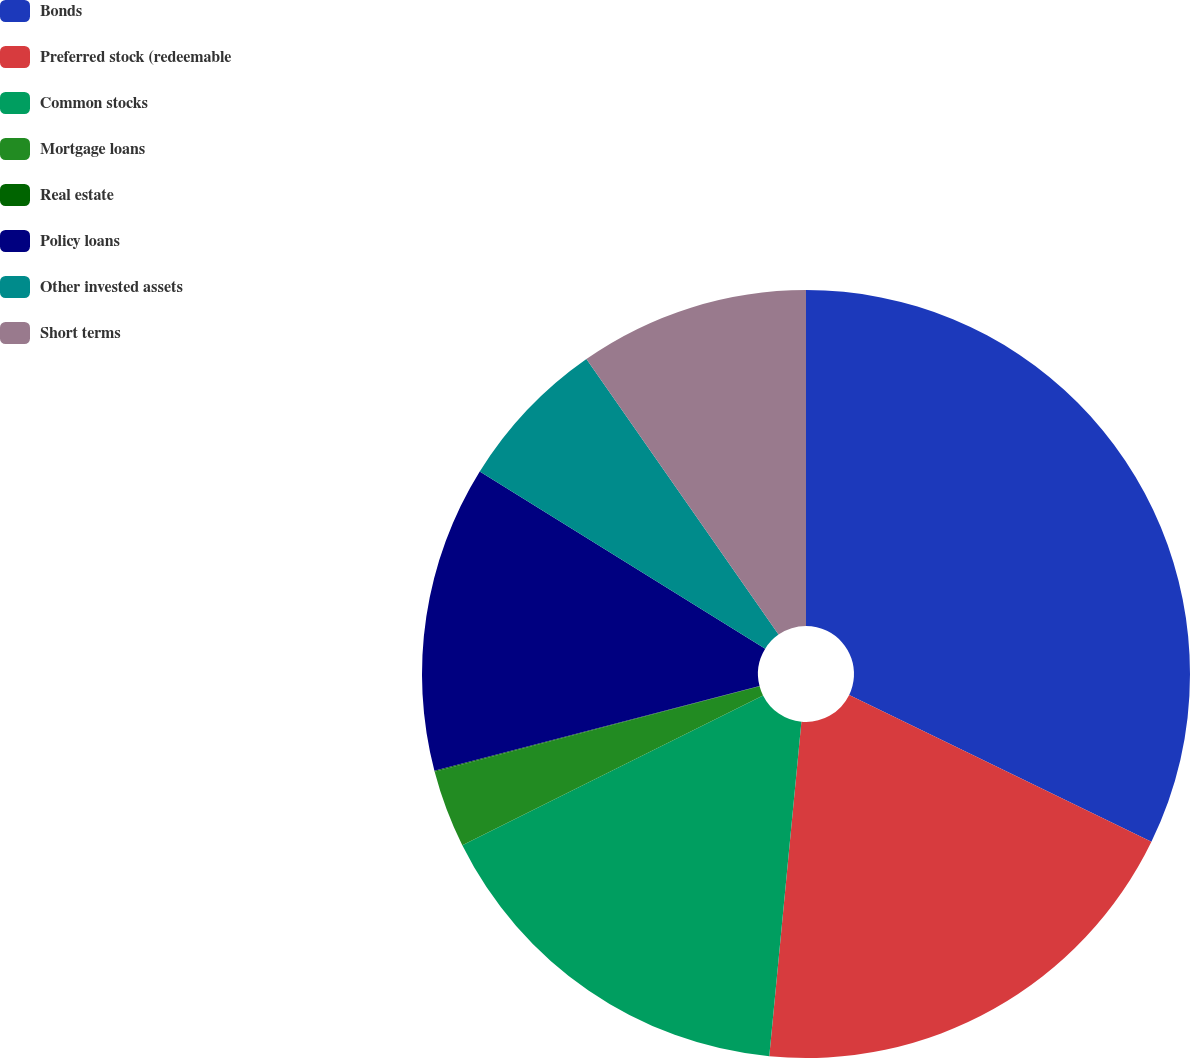Convert chart. <chart><loc_0><loc_0><loc_500><loc_500><pie_chart><fcel>Bonds<fcel>Preferred stock (redeemable<fcel>Common stocks<fcel>Mortgage loans<fcel>Real estate<fcel>Policy loans<fcel>Other invested assets<fcel>Short terms<nl><fcel>32.2%<fcel>19.33%<fcel>16.12%<fcel>3.26%<fcel>0.04%<fcel>12.9%<fcel>6.47%<fcel>9.69%<nl></chart> 